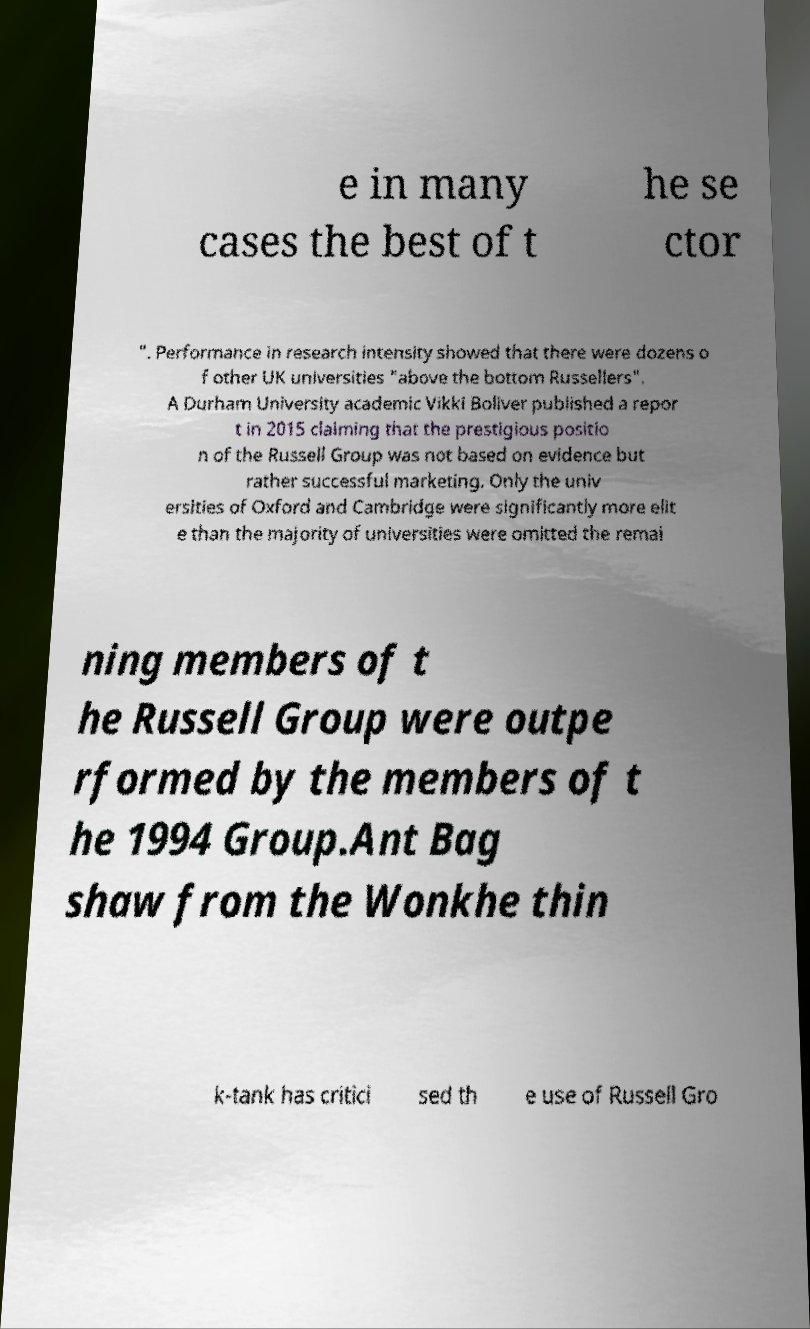I need the written content from this picture converted into text. Can you do that? e in many cases the best of t he se ctor ". Performance in research intensity showed that there were dozens o f other UK universities "above the bottom Russellers". A Durham University academic Vikki Boliver published a repor t in 2015 claiming that the prestigious positio n of the Russell Group was not based on evidence but rather successful marketing. Only the univ ersities of Oxford and Cambridge were significantly more elit e than the majority of universities were omitted the remai ning members of t he Russell Group were outpe rformed by the members of t he 1994 Group.Ant Bag shaw from the Wonkhe thin k-tank has critici sed th e use of Russell Gro 